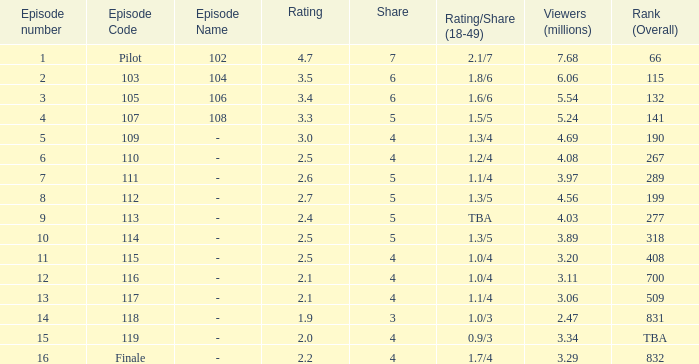WHAT IS THE NUMBER OF VIEWERS WITH EPISODE LARGER THAN 10, RATING SMALLER THAN 2? 2.47. 